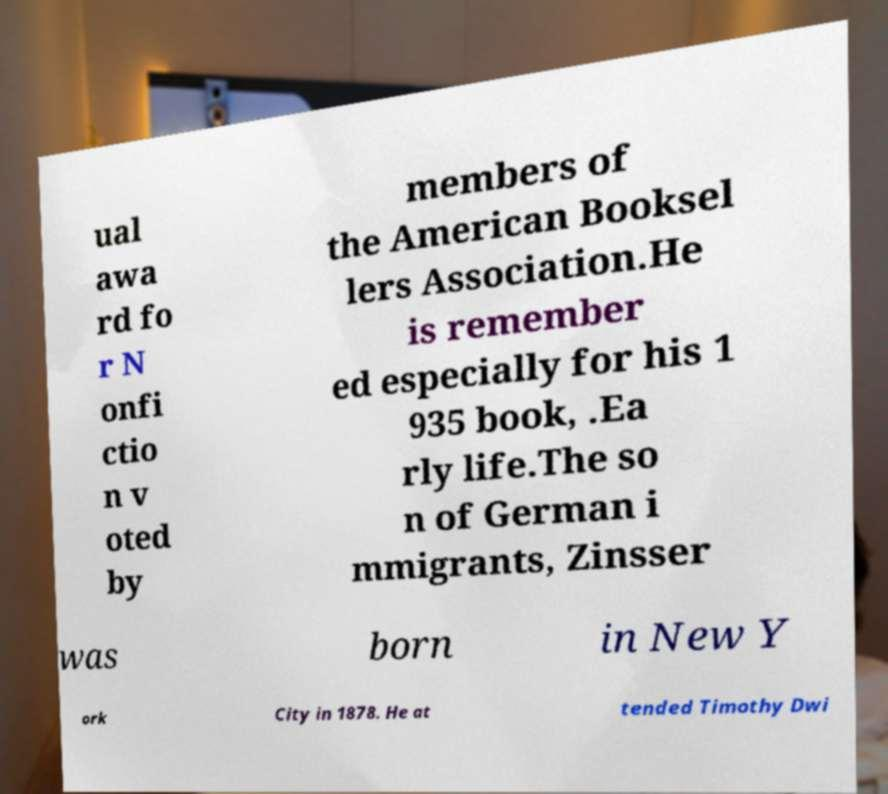For documentation purposes, I need the text within this image transcribed. Could you provide that? ual awa rd fo r N onfi ctio n v oted by members of the American Booksel lers Association.He is remember ed especially for his 1 935 book, .Ea rly life.The so n of German i mmigrants, Zinsser was born in New Y ork City in 1878. He at tended Timothy Dwi 